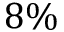Convert formula to latex. <formula><loc_0><loc_0><loc_500><loc_500>8 \%</formula> 